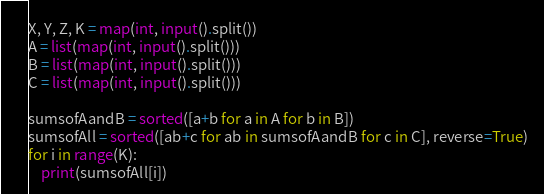Convert code to text. <code><loc_0><loc_0><loc_500><loc_500><_Python_>X, Y, Z, K = map(int, input().split())
A = list(map(int, input().split()))
B = list(map(int, input().split()))
C = list(map(int, input().split()))

sumsofAandB = sorted([a+b for a in A for b in B])
sumsofAll = sorted([ab+c for ab in sumsofAandB for c in C], reverse=True)
for i in range(K):
    print(sumsofAll[i])</code> 